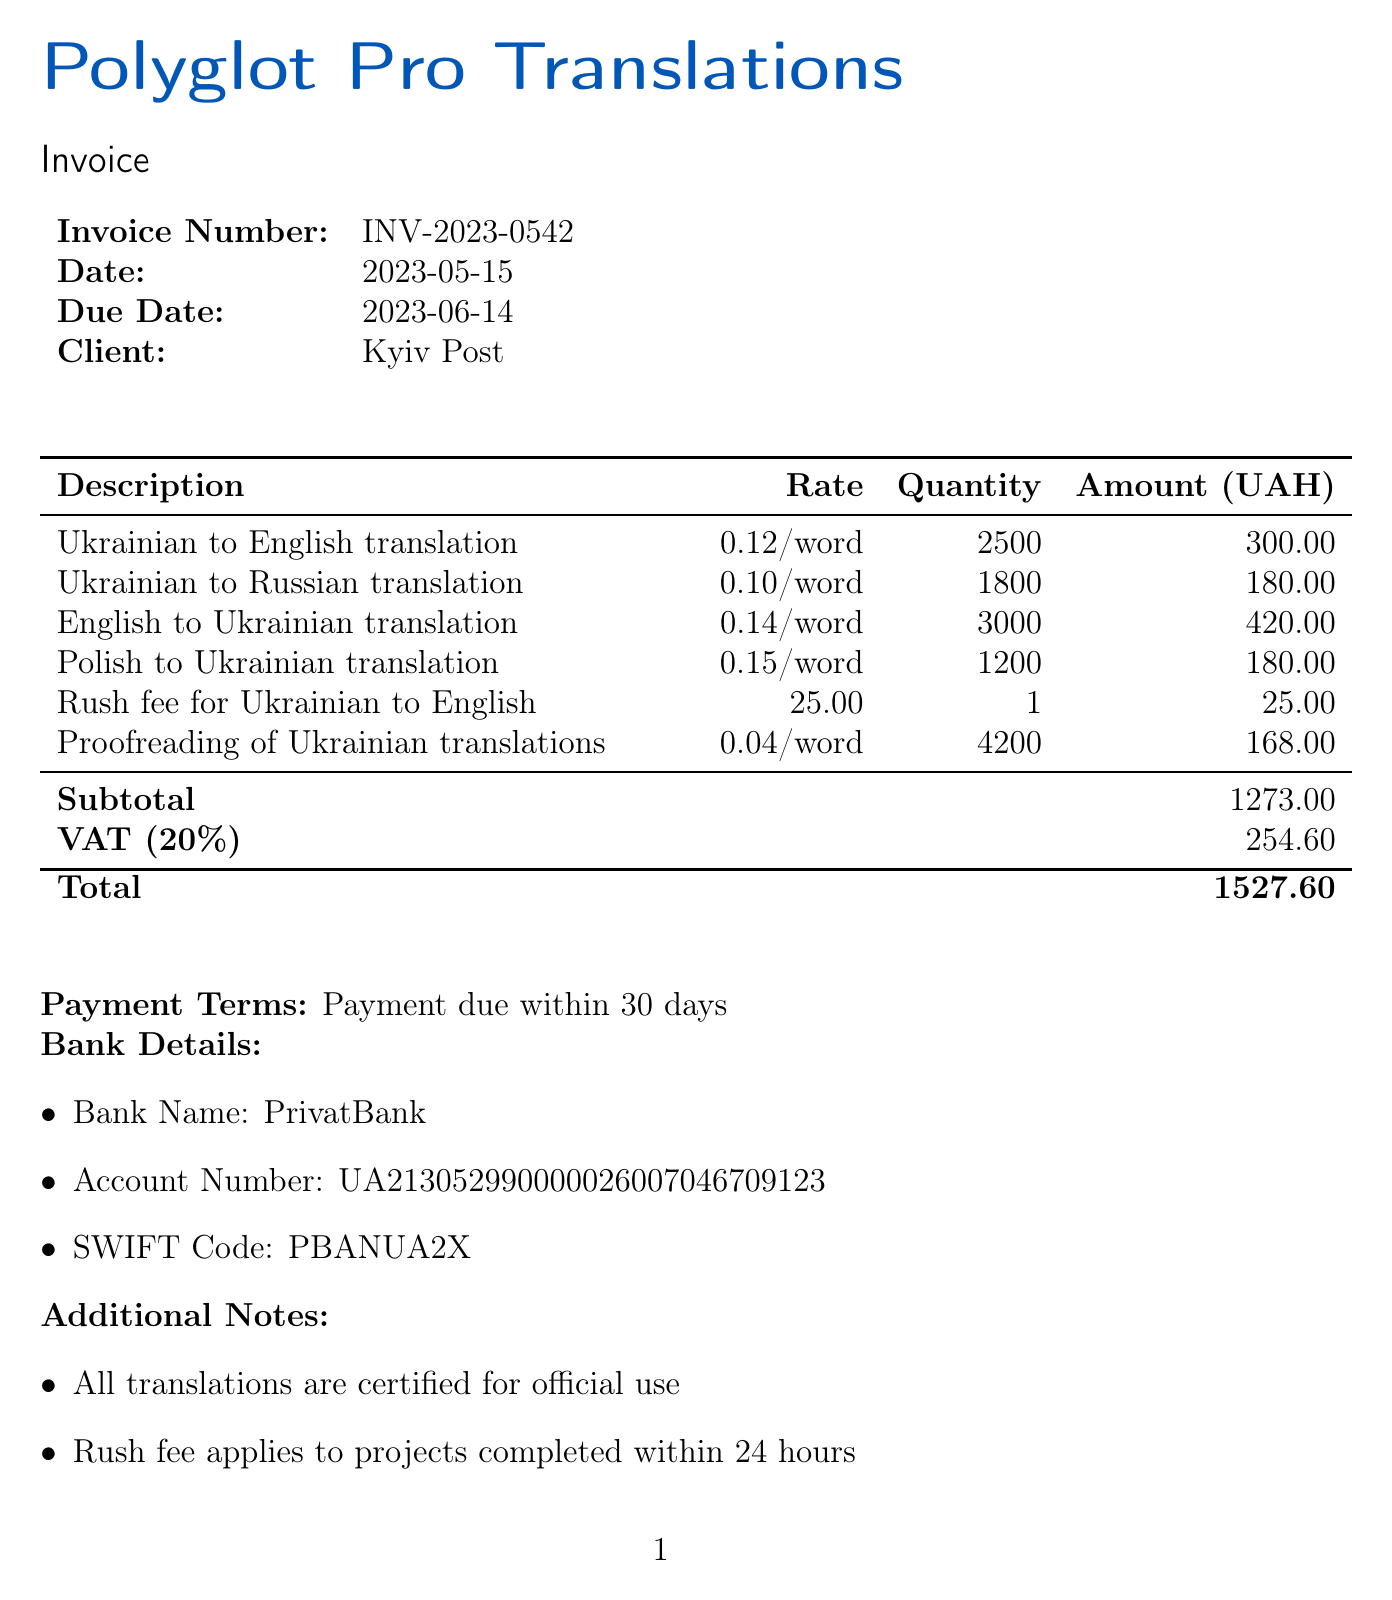What is the invoice number? The invoice number is a unique identifier for this invoice, which is listed in the document.
Answer: INV-2023-0542 What is the total amount due? The total amount due is calculated by adding the subtotal and VAT, and it is specified in the document.
Answer: 1527.60 What is the rush fee for translations? The document specifies an additional charge for expedited services, which is listed under the relevant item.
Answer: 25 What languages are included in the translation services? The document lists various language pairs for the translation services provided.
Answer: Ukrainian to English, Ukrainian to Russian, English to Ukrainian, Polish to Ukrainian How many words were translated from Ukrainian to English? The number of words is detailed in the description of the translation services provided for that language.
Answer: 2500 What is the VAT rate applied to the invoice? The VAT rate is mentioned in the totals section of the document.
Answer: 20 What is the payment deadline? The payment terms indicate when the payment is due, which is included in the invoice.
Answer: 30 days What bank is specified for the payment? The bank details section provides the name of the bank where payments should be made.
Answer: PrivatBank What type of translations does the company specialize in? The additional notes at the bottom of the invoice specify the company's areas of expertise.
Answer: Journalistic, legal, and diplomatic translations 